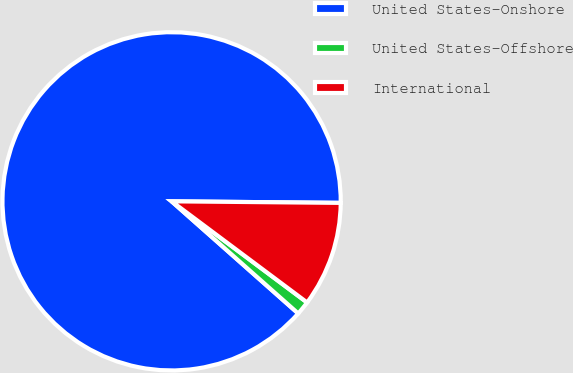<chart> <loc_0><loc_0><loc_500><loc_500><pie_chart><fcel>United States-Onshore<fcel>United States-Offshore<fcel>International<nl><fcel>88.61%<fcel>1.33%<fcel>10.06%<nl></chart> 